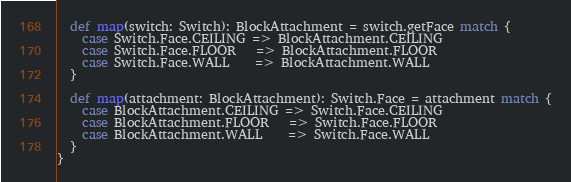Convert code to text. <code><loc_0><loc_0><loc_500><loc_500><_Scala_>  def map(switch: Switch): BlockAttachment = switch.getFace match {
    case Switch.Face.CEILING => BlockAttachment.CEILING
    case Switch.Face.FLOOR   => BlockAttachment.FLOOR
    case Switch.Face.WALL    => BlockAttachment.WALL
  }

  def map(attachment: BlockAttachment): Switch.Face = attachment match {
    case BlockAttachment.CEILING => Switch.Face.CEILING
    case BlockAttachment.FLOOR   => Switch.Face.FLOOR
    case BlockAttachment.WALL    => Switch.Face.WALL
  }
}
</code> 